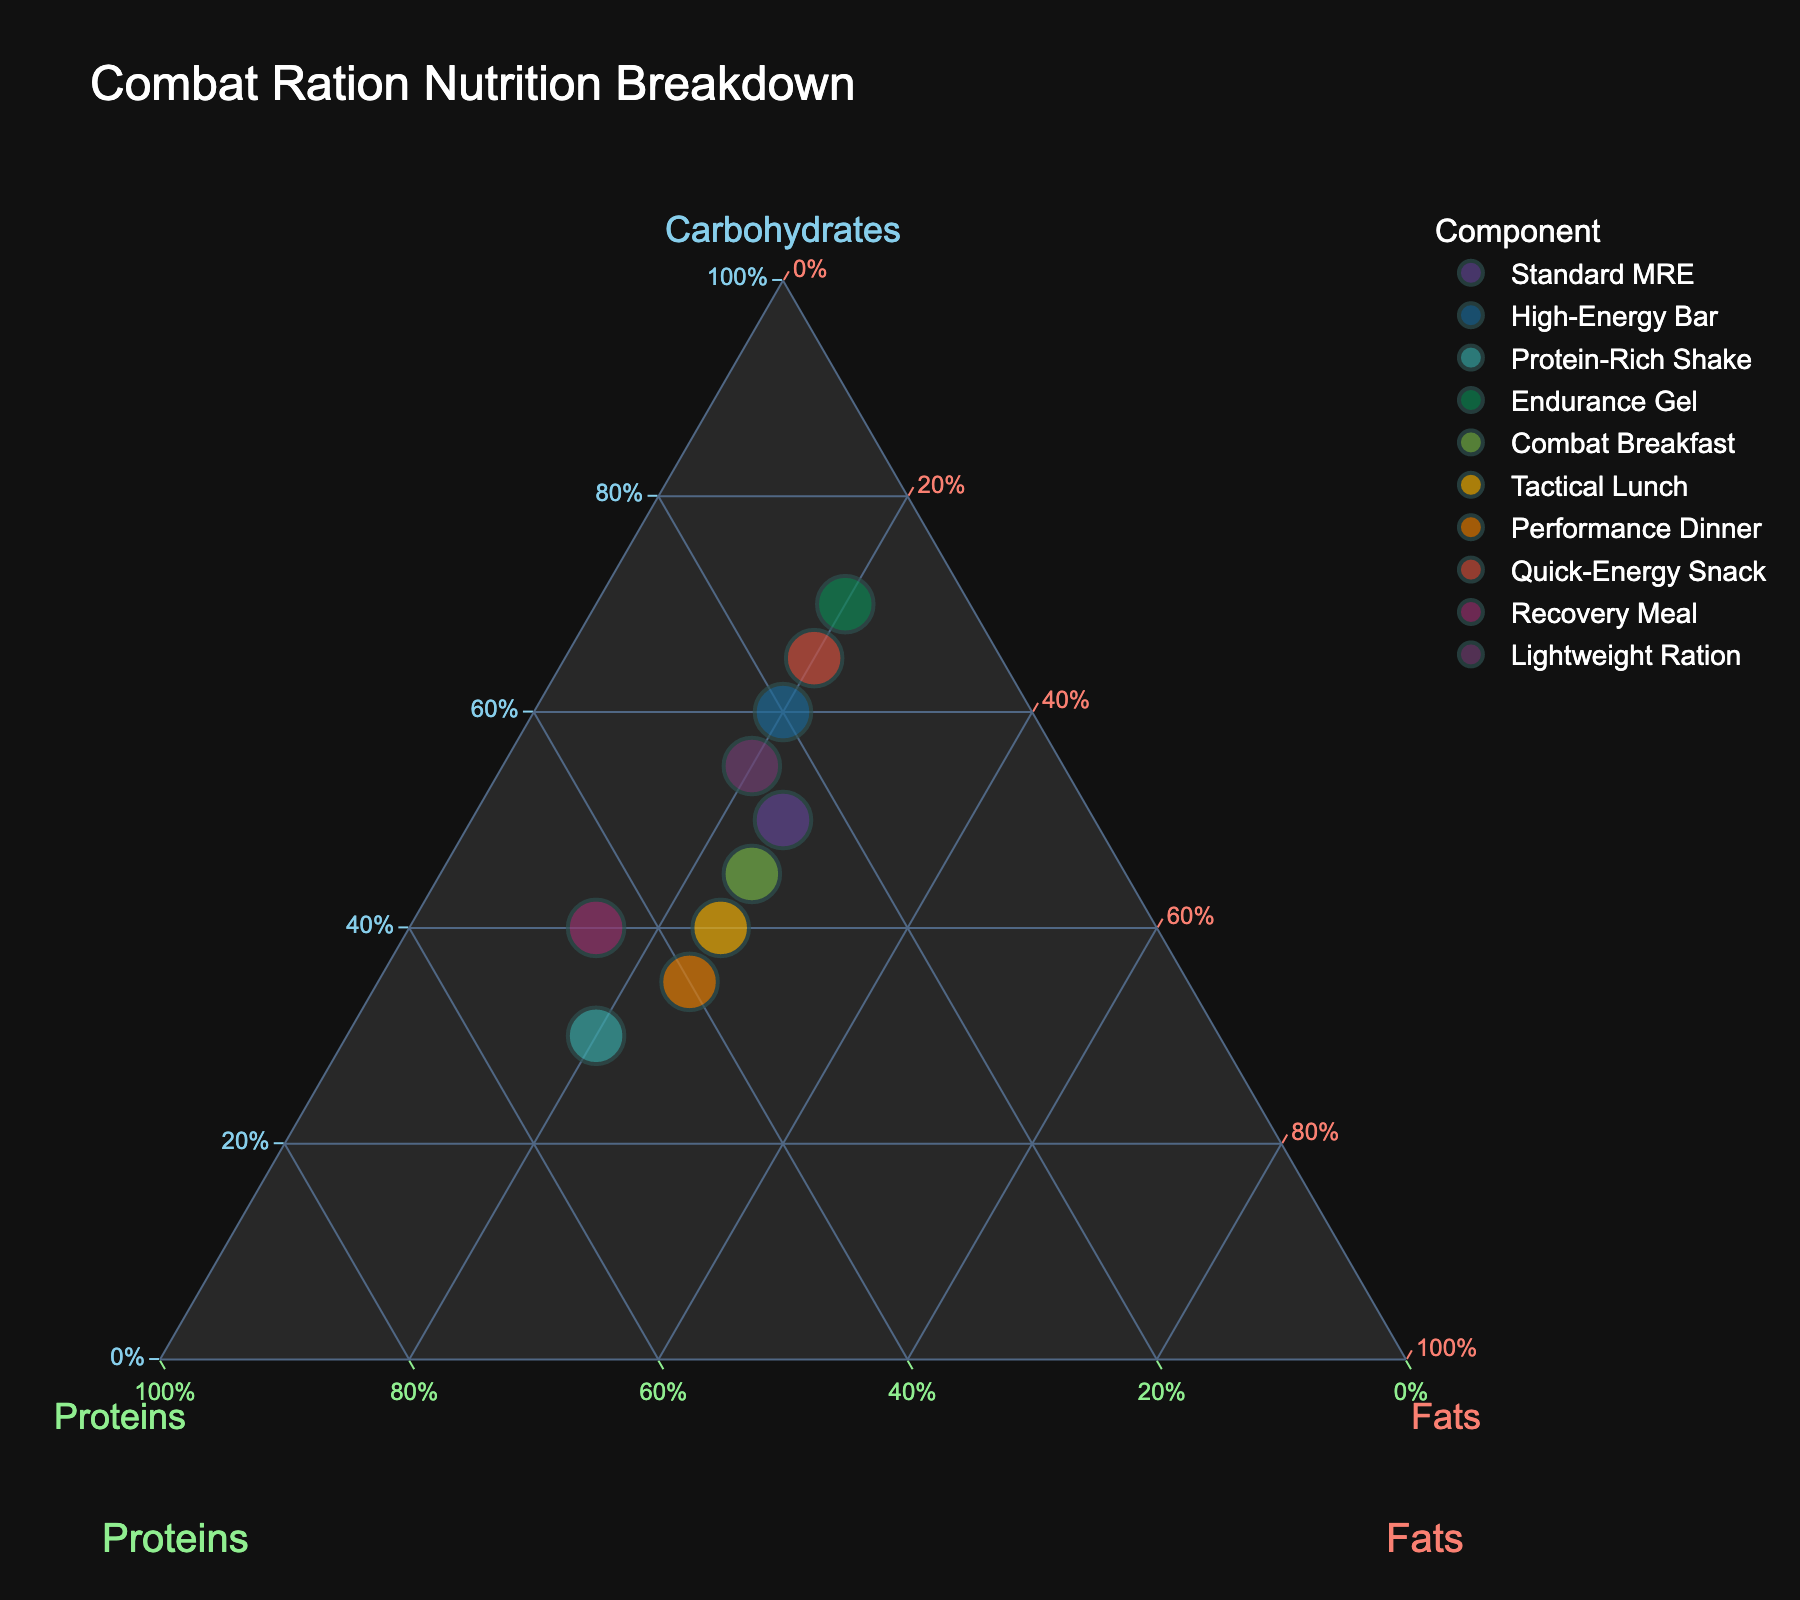What are the three components of the combat ration nutrition breakdown shown in the plot? The three components are labeled at the axes of the ternary plot: Carbohydrates, Proteins, and Fats.
Answer: Carbohydrates, Proteins, Fats How many different combat rations are shown in the figure? Each point on the plot represents one combat ration, and the hover information lists each. By counting the unique points or names in the hover data, we find there are 10 different combat rations.
Answer: 10 Which combat ration has the highest percentage of carbohydrates? By observing the position closest to the Carbohydrates axis apex, the "Endurance Gel" is positioned at the highest point, indicating 70% carbohydrates.
Answer: Endurance Gel What is the average percentage of fats across all combat rations? The percentages of fats are: 25, 20, 20, 20, 25, 25, 25, 20, 15, 20. Summing these up, we get 215%. Dividing by the 10 rations, the average percentage is 215/10 = 21.5%
Answer: 21.5% Which combat rations have exactly 20% fats? By examining the points positioned such that the total displayed percentage of fats is 20%, we see "High-Energy Bar," "Protein-Rich Shake," "Endurance Gel," and "Quick-Energy Snack."
Answer: High-Energy Bar, Protein-Rich Shake, Endurance Gel, Quick-Energy Snack How does the carbohydrate content of the "Protein-Rich Shake" compare to the "High-Energy Bar"? The "Protein-Rich Shake" has 30% carbohydrates, and the "High-Energy Bar" has 60%. Thus, the "Protein-Rich Shake" has less carbohydrates than the "High-Energy Bar."
Answer: Less What is the combined percentage of proteins and fats in the "Tactical Lunch"? The "Tactical Lunch" has 35% proteins and 25% fats. Adding these, 35% + 25% = 60%.
Answer: 60% Which combat ration places the highest emphasis on proteins? By identifying the point closest to the Proteins axis apex, the "Protein-Rich Shake" is observed to have the highest protein content of 50%.
Answer: Protein-Rich Shake Are there any combat rations with equal percentages of proteins and fats? By examining the points where the percentages of proteins and fats are equal, the "Standard MRE" has 25% proteins and 25% fats.
Answer: Standard MRE How does the nutrition composition of "Performance Dinner" differ from "Recovery Meal"? "Performance Dinner" has 35% carbohydrates, 40% proteins, and 25% fats. "Recovery Meal" has 40% carbohydrates, 45% proteins, and 15% fats. Therefore, "Recovery Meal" has 5% more carbohydrates, 5% more proteins, and 10% less fats than "Performance Dinner.”
Answer: "Recovery Meal" has 5% more carbohydrates, 5% more proteins, 10% less fats 